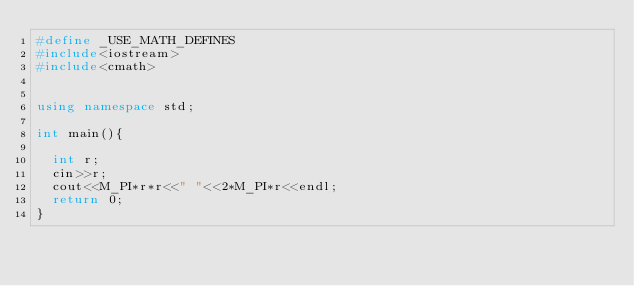<code> <loc_0><loc_0><loc_500><loc_500><_C++_>#define _USE_MATH_DEFINES
#include<iostream>
#include<cmath>


using namespace std;

int main(){

	int r;
	cin>>r;
	cout<<M_PI*r*r<<" "<<2*M_PI*r<<endl;
	return 0;
}</code> 